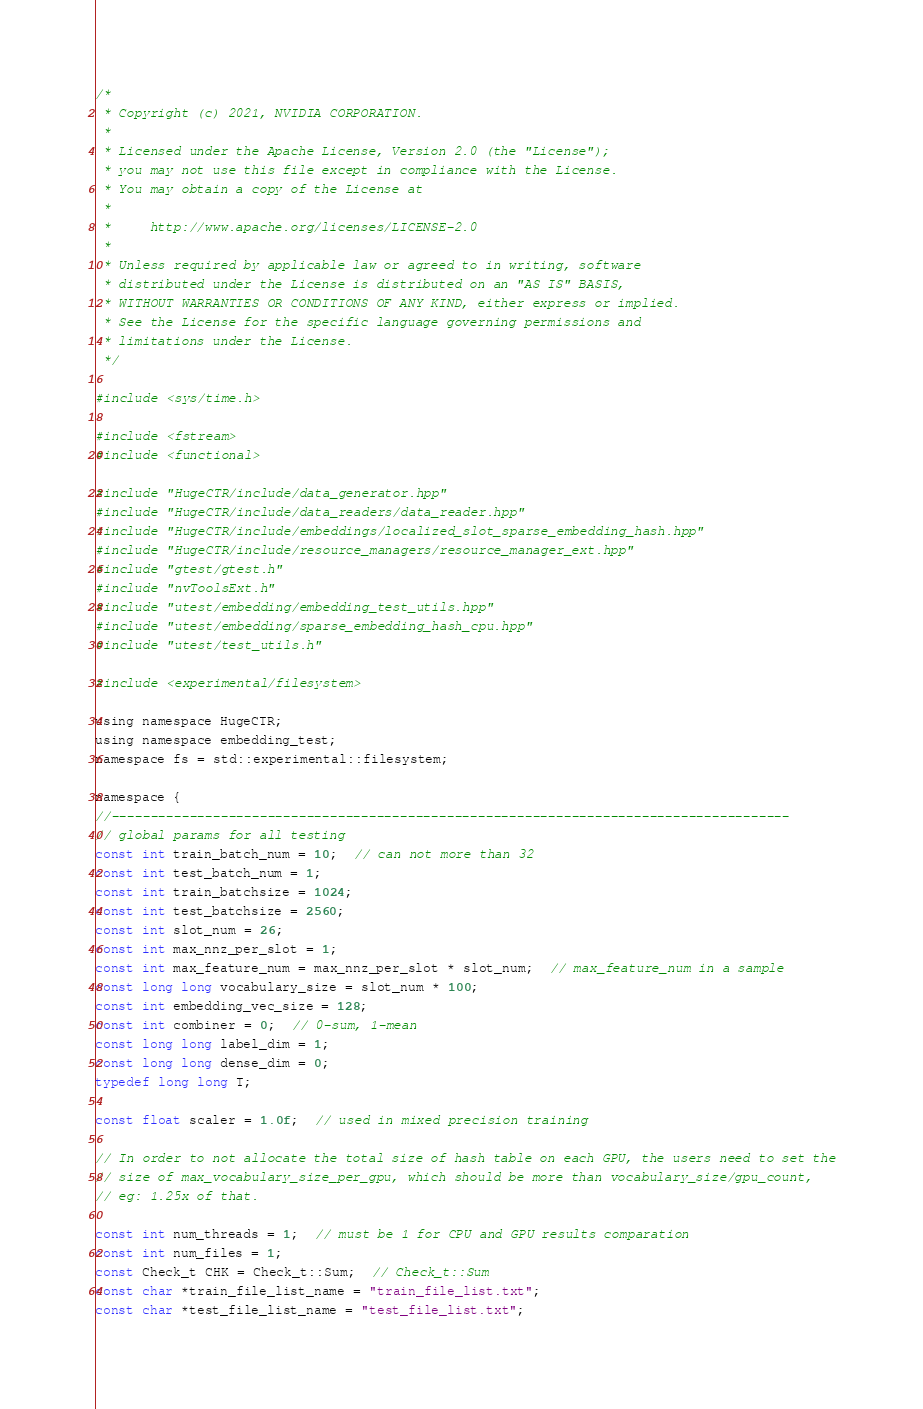<code> <loc_0><loc_0><loc_500><loc_500><_Cuda_>/*
 * Copyright (c) 2021, NVIDIA CORPORATION.
 *
 * Licensed under the Apache License, Version 2.0 (the "License");
 * you may not use this file except in compliance with the License.
 * You may obtain a copy of the License at
 *
 *     http://www.apache.org/licenses/LICENSE-2.0
 *
 * Unless required by applicable law or agreed to in writing, software
 * distributed under the License is distributed on an "AS IS" BASIS,
 * WITHOUT WARRANTIES OR CONDITIONS OF ANY KIND, either express or implied.
 * See the License for the specific language governing permissions and
 * limitations under the License.
 */

#include <sys/time.h>

#include <fstream>
#include <functional>

#include "HugeCTR/include/data_generator.hpp"
#include "HugeCTR/include/data_readers/data_reader.hpp"
#include "HugeCTR/include/embeddings/localized_slot_sparse_embedding_hash.hpp"
#include "HugeCTR/include/resource_managers/resource_manager_ext.hpp"
#include "gtest/gtest.h"
#include "nvToolsExt.h"
#include "utest/embedding/embedding_test_utils.hpp"
#include "utest/embedding/sparse_embedding_hash_cpu.hpp"
#include "utest/test_utils.h"

#include <experimental/filesystem>

using namespace HugeCTR;
using namespace embedding_test;
namespace fs = std::experimental::filesystem;

namespace {
//---------------------------------------------------------------------------------------
// global params for all testing
const int train_batch_num = 10;  // can not more than 32
const int test_batch_num = 1;
const int train_batchsize = 1024;
const int test_batchsize = 2560;
const int slot_num = 26;
const int max_nnz_per_slot = 1;
const int max_feature_num = max_nnz_per_slot * slot_num;  // max_feature_num in a sample
const long long vocabulary_size = slot_num * 100;
const int embedding_vec_size = 128;
const int combiner = 0;  // 0-sum, 1-mean
const long long label_dim = 1;
const long long dense_dim = 0;
typedef long long T;

const float scaler = 1.0f;  // used in mixed precision training

// In order to not allocate the total size of hash table on each GPU, the users need to set the
// size of max_vocabulary_size_per_gpu, which should be more than vocabulary_size/gpu_count,
// eg: 1.25x of that.

const int num_threads = 1;  // must be 1 for CPU and GPU results comparation
const int num_files = 1;
const Check_t CHK = Check_t::Sum;  // Check_t::Sum
const char *train_file_list_name = "train_file_list.txt";
const char *test_file_list_name = "test_file_list.txt";</code> 